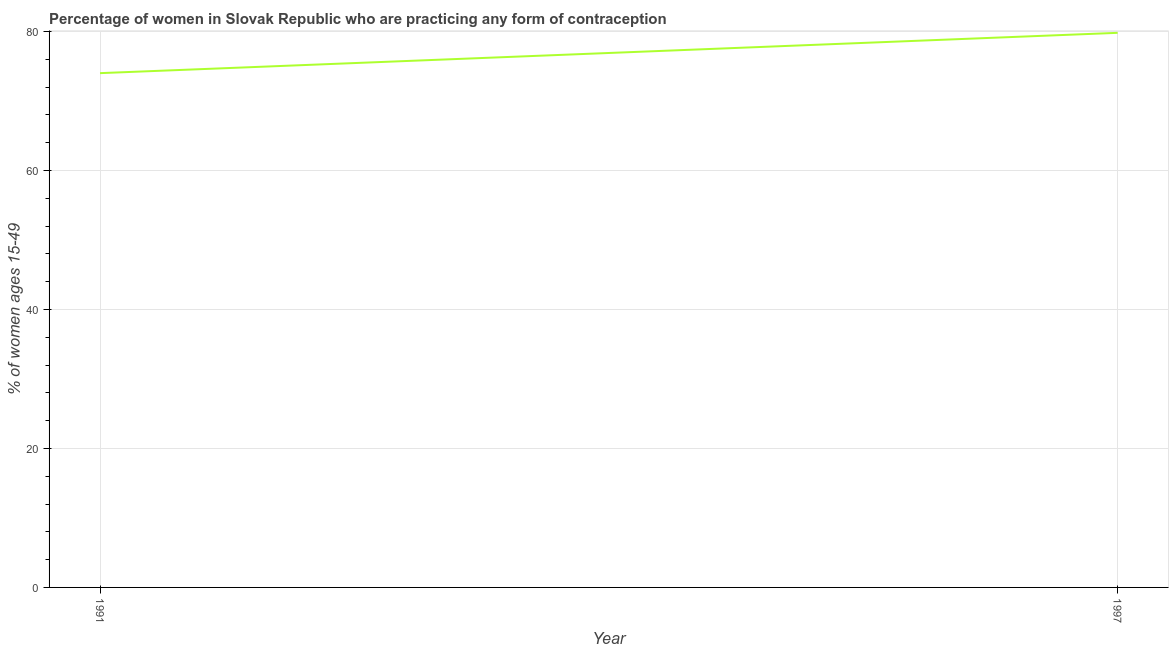What is the contraceptive prevalence in 1991?
Provide a succinct answer. 74. Across all years, what is the maximum contraceptive prevalence?
Your answer should be very brief. 79.8. Across all years, what is the minimum contraceptive prevalence?
Keep it short and to the point. 74. What is the sum of the contraceptive prevalence?
Offer a terse response. 153.8. What is the difference between the contraceptive prevalence in 1991 and 1997?
Offer a very short reply. -5.8. What is the average contraceptive prevalence per year?
Ensure brevity in your answer.  76.9. What is the median contraceptive prevalence?
Provide a succinct answer. 76.9. What is the ratio of the contraceptive prevalence in 1991 to that in 1997?
Your answer should be very brief. 0.93. In how many years, is the contraceptive prevalence greater than the average contraceptive prevalence taken over all years?
Provide a short and direct response. 1. How many lines are there?
Keep it short and to the point. 1. What is the difference between two consecutive major ticks on the Y-axis?
Make the answer very short. 20. Are the values on the major ticks of Y-axis written in scientific E-notation?
Offer a terse response. No. Does the graph contain grids?
Your answer should be very brief. Yes. What is the title of the graph?
Your response must be concise. Percentage of women in Slovak Republic who are practicing any form of contraception. What is the label or title of the Y-axis?
Keep it short and to the point. % of women ages 15-49. What is the % of women ages 15-49 of 1997?
Your answer should be very brief. 79.8. What is the ratio of the % of women ages 15-49 in 1991 to that in 1997?
Make the answer very short. 0.93. 